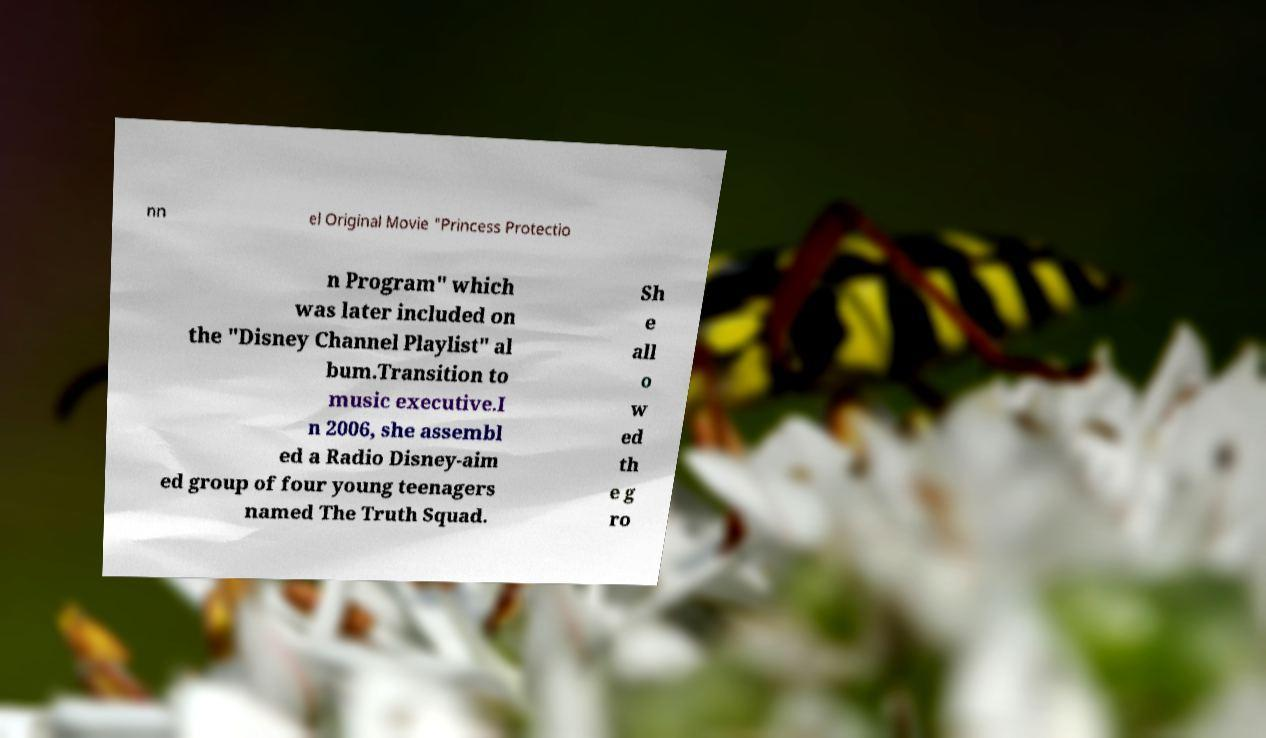Can you read and provide the text displayed in the image?This photo seems to have some interesting text. Can you extract and type it out for me? nn el Original Movie "Princess Protectio n Program" which was later included on the "Disney Channel Playlist" al bum.Transition to music executive.I n 2006, she assembl ed a Radio Disney-aim ed group of four young teenagers named The Truth Squad. Sh e all o w ed th e g ro 